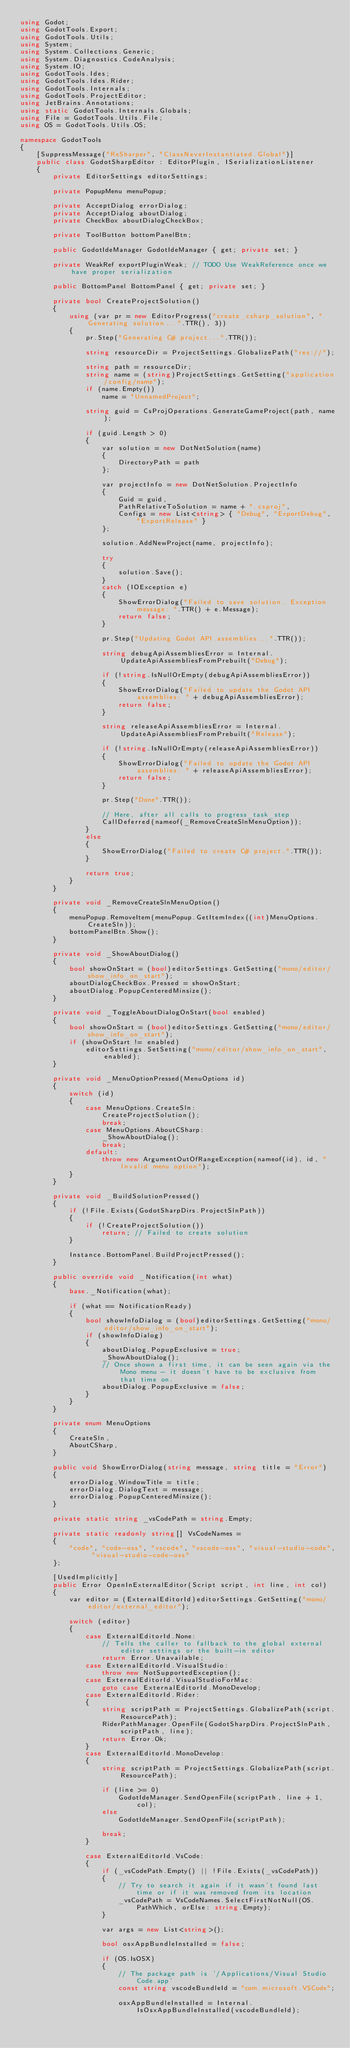<code> <loc_0><loc_0><loc_500><loc_500><_C#_>using Godot;
using GodotTools.Export;
using GodotTools.Utils;
using System;
using System.Collections.Generic;
using System.Diagnostics.CodeAnalysis;
using System.IO;
using GodotTools.Ides;
using GodotTools.Ides.Rider;
using GodotTools.Internals;
using GodotTools.ProjectEditor;
using JetBrains.Annotations;
using static GodotTools.Internals.Globals;
using File = GodotTools.Utils.File;
using OS = GodotTools.Utils.OS;

namespace GodotTools
{
    [SuppressMessage("ReSharper", "ClassNeverInstantiated.Global")]
    public class GodotSharpEditor : EditorPlugin, ISerializationListener
    {
        private EditorSettings editorSettings;

        private PopupMenu menuPopup;

        private AcceptDialog errorDialog;
        private AcceptDialog aboutDialog;
        private CheckBox aboutDialogCheckBox;

        private ToolButton bottomPanelBtn;

        public GodotIdeManager GodotIdeManager { get; private set; }

        private WeakRef exportPluginWeak; // TODO Use WeakReference once we have proper serialization

        public BottomPanel BottomPanel { get; private set; }

        private bool CreateProjectSolution()
        {
            using (var pr = new EditorProgress("create_csharp_solution", "Generating solution...".TTR(), 3))
            {
                pr.Step("Generating C# project...".TTR());

                string resourceDir = ProjectSettings.GlobalizePath("res://");

                string path = resourceDir;
                string name = (string)ProjectSettings.GetSetting("application/config/name");
                if (name.Empty())
                    name = "UnnamedProject";

                string guid = CsProjOperations.GenerateGameProject(path, name);

                if (guid.Length > 0)
                {
                    var solution = new DotNetSolution(name)
                    {
                        DirectoryPath = path
                    };

                    var projectInfo = new DotNetSolution.ProjectInfo
                    {
                        Guid = guid,
                        PathRelativeToSolution = name + ".csproj",
                        Configs = new List<string> { "Debug", "ExportDebug", "ExportRelease" }
                    };

                    solution.AddNewProject(name, projectInfo);

                    try
                    {
                        solution.Save();
                    }
                    catch (IOException e)
                    {
                        ShowErrorDialog("Failed to save solution. Exception message: ".TTR() + e.Message);
                        return false;
                    }

                    pr.Step("Updating Godot API assemblies...".TTR());

                    string debugApiAssembliesError = Internal.UpdateApiAssembliesFromPrebuilt("Debug");

                    if (!string.IsNullOrEmpty(debugApiAssembliesError))
                    {
                        ShowErrorDialog("Failed to update the Godot API assemblies: " + debugApiAssembliesError);
                        return false;
                    }

                    string releaseApiAssembliesError = Internal.UpdateApiAssembliesFromPrebuilt("Release");

                    if (!string.IsNullOrEmpty(releaseApiAssembliesError))
                    {
                        ShowErrorDialog("Failed to update the Godot API assemblies: " + releaseApiAssembliesError);
                        return false;
                    }

                    pr.Step("Done".TTR());

                    // Here, after all calls to progress_task_step
                    CallDeferred(nameof(_RemoveCreateSlnMenuOption));
                }
                else
                {
                    ShowErrorDialog("Failed to create C# project.".TTR());
                }

                return true;
            }
        }

        private void _RemoveCreateSlnMenuOption()
        {
            menuPopup.RemoveItem(menuPopup.GetItemIndex((int)MenuOptions.CreateSln));
            bottomPanelBtn.Show();
        }

        private void _ShowAboutDialog()
        {
            bool showOnStart = (bool)editorSettings.GetSetting("mono/editor/show_info_on_start");
            aboutDialogCheckBox.Pressed = showOnStart;
            aboutDialog.PopupCenteredMinsize();
        }

        private void _ToggleAboutDialogOnStart(bool enabled)
        {
            bool showOnStart = (bool)editorSettings.GetSetting("mono/editor/show_info_on_start");
            if (showOnStart != enabled)
                editorSettings.SetSetting("mono/editor/show_info_on_start", enabled);
        }

        private void _MenuOptionPressed(MenuOptions id)
        {
            switch (id)
            {
                case MenuOptions.CreateSln:
                    CreateProjectSolution();
                    break;
                case MenuOptions.AboutCSharp:
                    _ShowAboutDialog();
                    break;
                default:
                    throw new ArgumentOutOfRangeException(nameof(id), id, "Invalid menu option");
            }
        }

        private void _BuildSolutionPressed()
        {
            if (!File.Exists(GodotSharpDirs.ProjectSlnPath))
            {
                if (!CreateProjectSolution())
                    return; // Failed to create solution
            }

            Instance.BottomPanel.BuildProjectPressed();
        }

        public override void _Notification(int what)
        {
            base._Notification(what);

            if (what == NotificationReady)
            {
                bool showInfoDialog = (bool)editorSettings.GetSetting("mono/editor/show_info_on_start");
                if (showInfoDialog)
                {
                    aboutDialog.PopupExclusive = true;
                    _ShowAboutDialog();
                    // Once shown a first time, it can be seen again via the Mono menu - it doesn't have to be exclusive from that time on.
                    aboutDialog.PopupExclusive = false;
                }
            }
        }

        private enum MenuOptions
        {
            CreateSln,
            AboutCSharp,
        }

        public void ShowErrorDialog(string message, string title = "Error")
        {
            errorDialog.WindowTitle = title;
            errorDialog.DialogText = message;
            errorDialog.PopupCenteredMinsize();
        }

        private static string _vsCodePath = string.Empty;

        private static readonly string[] VsCodeNames =
        {
            "code", "code-oss", "vscode", "vscode-oss", "visual-studio-code", "visual-studio-code-oss"
        };

        [UsedImplicitly]
        public Error OpenInExternalEditor(Script script, int line, int col)
        {
            var editor = (ExternalEditorId)editorSettings.GetSetting("mono/editor/external_editor");

            switch (editor)
            {
                case ExternalEditorId.None:
                    // Tells the caller to fallback to the global external editor settings or the built-in editor
                    return Error.Unavailable;
                case ExternalEditorId.VisualStudio:
                    throw new NotSupportedException();
                case ExternalEditorId.VisualStudioForMac:
                    goto case ExternalEditorId.MonoDevelop;
                case ExternalEditorId.Rider:
                {
                    string scriptPath = ProjectSettings.GlobalizePath(script.ResourcePath);
                    RiderPathManager.OpenFile(GodotSharpDirs.ProjectSlnPath, scriptPath, line);
                    return Error.Ok;
                }        
                case ExternalEditorId.MonoDevelop:
                {
                    string scriptPath = ProjectSettings.GlobalizePath(script.ResourcePath);

                    if (line >= 0)
                        GodotIdeManager.SendOpenFile(scriptPath, line + 1, col);
                    else
                        GodotIdeManager.SendOpenFile(scriptPath);

                    break;
                }

                case ExternalEditorId.VsCode:
                {
                    if (_vsCodePath.Empty() || !File.Exists(_vsCodePath))
                    {
                        // Try to search it again if it wasn't found last time or if it was removed from its location
                        _vsCodePath = VsCodeNames.SelectFirstNotNull(OS.PathWhich, orElse: string.Empty);
                    }

                    var args = new List<string>();

                    bool osxAppBundleInstalled = false;

                    if (OS.IsOSX)
                    {
                        // The package path is '/Applications/Visual Studio Code.app'
                        const string vscodeBundleId = "com.microsoft.VSCode";

                        osxAppBundleInstalled = Internal.IsOsxAppBundleInstalled(vscodeBundleId);
</code> 